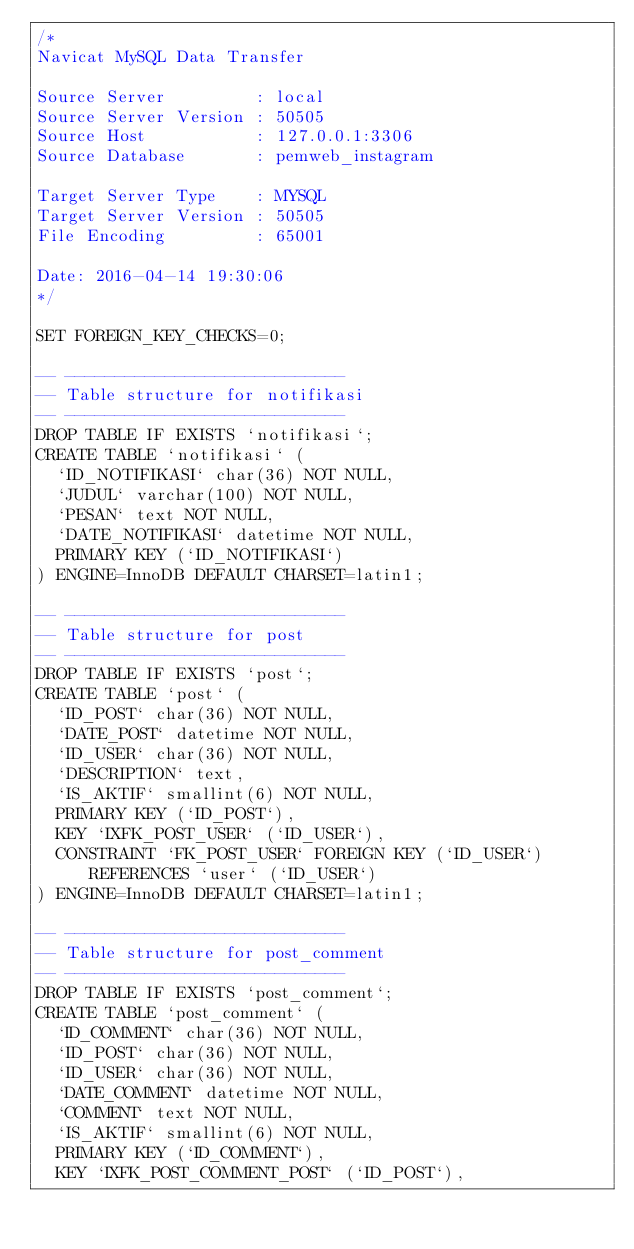Convert code to text. <code><loc_0><loc_0><loc_500><loc_500><_SQL_>/*
Navicat MySQL Data Transfer

Source Server         : local
Source Server Version : 50505
Source Host           : 127.0.0.1:3306
Source Database       : pemweb_instagram

Target Server Type    : MYSQL
Target Server Version : 50505
File Encoding         : 65001

Date: 2016-04-14 19:30:06
*/

SET FOREIGN_KEY_CHECKS=0;

-- ----------------------------
-- Table structure for notifikasi
-- ----------------------------
DROP TABLE IF EXISTS `notifikasi`;
CREATE TABLE `notifikasi` (
  `ID_NOTIFIKASI` char(36) NOT NULL,
  `JUDUL` varchar(100) NOT NULL,
  `PESAN` text NOT NULL,
  `DATE_NOTIFIKASI` datetime NOT NULL,
  PRIMARY KEY (`ID_NOTIFIKASI`)
) ENGINE=InnoDB DEFAULT CHARSET=latin1;

-- ----------------------------
-- Table structure for post
-- ----------------------------
DROP TABLE IF EXISTS `post`;
CREATE TABLE `post` (
  `ID_POST` char(36) NOT NULL,
  `DATE_POST` datetime NOT NULL,
  `ID_USER` char(36) NOT NULL,
  `DESCRIPTION` text,
  `IS_AKTIF` smallint(6) NOT NULL,
  PRIMARY KEY (`ID_POST`),
  KEY `IXFK_POST_USER` (`ID_USER`),
  CONSTRAINT `FK_POST_USER` FOREIGN KEY (`ID_USER`) REFERENCES `user` (`ID_USER`)
) ENGINE=InnoDB DEFAULT CHARSET=latin1;

-- ----------------------------
-- Table structure for post_comment
-- ----------------------------
DROP TABLE IF EXISTS `post_comment`;
CREATE TABLE `post_comment` (
  `ID_COMMENT` char(36) NOT NULL,
  `ID_POST` char(36) NOT NULL,
  `ID_USER` char(36) NOT NULL,
  `DATE_COMMENT` datetime NOT NULL,
  `COMMENT` text NOT NULL,
  `IS_AKTIF` smallint(6) NOT NULL,
  PRIMARY KEY (`ID_COMMENT`),
  KEY `IXFK_POST_COMMENT_POST` (`ID_POST`),</code> 